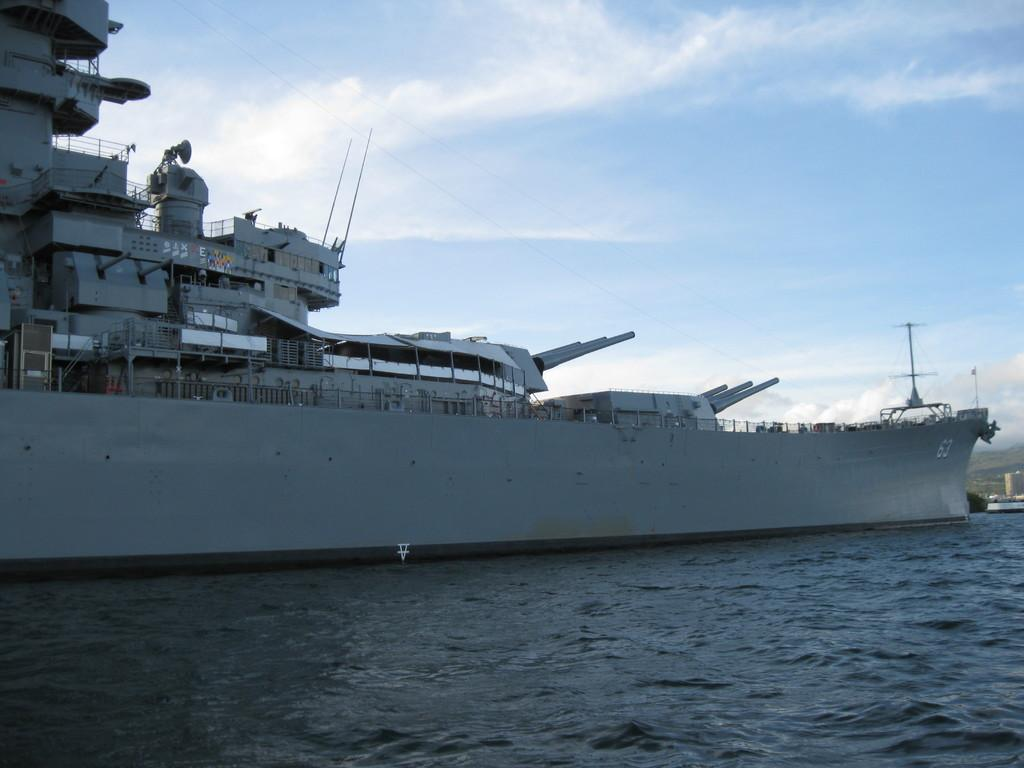What is the main feature of the image? The main feature of the image is an ocean. What is located in the ocean? There is a ship docked in the ocean. How would you describe the sky in the image? The sky is cloudy in the image. Where is the hospital located in the image? There is no hospital present in the image. What type of ball can be seen rolling on the ship? There is no ball present in the image. 